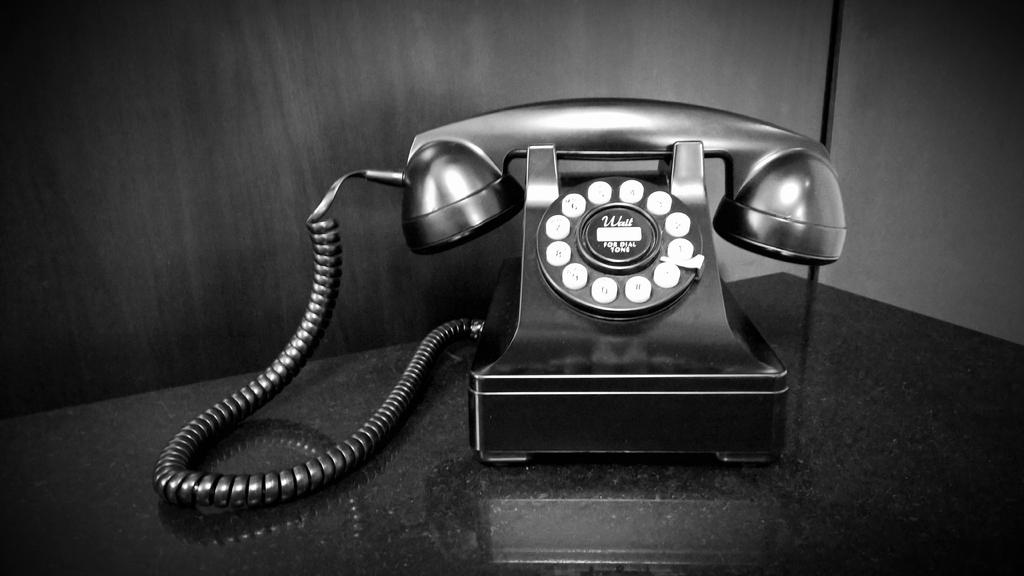What type of communication device is in the image? There is a telephone in the image. What feature does the telephone have for dialing numbers? The telephone has a dial pad for dialing numbers. What type of input method does the telephone have for selecting options? The telephone has buttons for selecting options. Is there any connection between the telephone and a power source? Yes, there is a wire associated with the telephone. Where is the telephone located in the image? The telephone is on a table. What can be seen in the background of the image? There is a wall visible in the background of the image. What color of paint is used on the dock in the image? There is no dock present in the image; it features a telephone on a table. How much debt is associated with the telephone in the image? There is no mention of debt associated with the telephone in the image. 